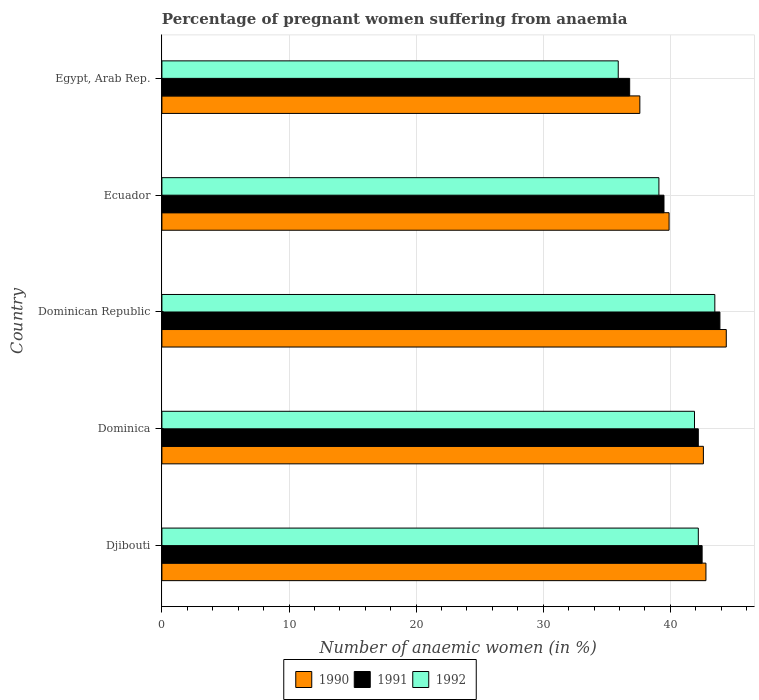How many groups of bars are there?
Offer a terse response. 5. How many bars are there on the 4th tick from the top?
Offer a very short reply. 3. How many bars are there on the 5th tick from the bottom?
Provide a succinct answer. 3. What is the label of the 2nd group of bars from the top?
Your answer should be compact. Ecuador. In how many cases, is the number of bars for a given country not equal to the number of legend labels?
Give a very brief answer. 0. What is the number of anaemic women in 1992 in Ecuador?
Offer a very short reply. 39.1. Across all countries, what is the maximum number of anaemic women in 1991?
Provide a succinct answer. 43.9. Across all countries, what is the minimum number of anaemic women in 1991?
Make the answer very short. 36.8. In which country was the number of anaemic women in 1990 maximum?
Provide a short and direct response. Dominican Republic. In which country was the number of anaemic women in 1992 minimum?
Your response must be concise. Egypt, Arab Rep. What is the total number of anaemic women in 1990 in the graph?
Ensure brevity in your answer.  207.3. What is the difference between the number of anaemic women in 1991 in Dominica and that in Dominican Republic?
Make the answer very short. -1.7. What is the difference between the number of anaemic women in 1992 in Djibouti and the number of anaemic women in 1991 in Ecuador?
Offer a very short reply. 2.7. What is the average number of anaemic women in 1992 per country?
Give a very brief answer. 40.52. What is the difference between the number of anaemic women in 1991 and number of anaemic women in 1992 in Ecuador?
Give a very brief answer. 0.4. In how many countries, is the number of anaemic women in 1991 greater than 8 %?
Your response must be concise. 5. What is the ratio of the number of anaemic women in 1991 in Dominican Republic to that in Ecuador?
Make the answer very short. 1.11. Is the number of anaemic women in 1990 in Dominica less than that in Ecuador?
Offer a very short reply. No. Is the difference between the number of anaemic women in 1991 in Dominica and Ecuador greater than the difference between the number of anaemic women in 1992 in Dominica and Ecuador?
Keep it short and to the point. No. What is the difference between the highest and the second highest number of anaemic women in 1990?
Offer a terse response. 1.6. What is the difference between the highest and the lowest number of anaemic women in 1992?
Your response must be concise. 7.6. In how many countries, is the number of anaemic women in 1990 greater than the average number of anaemic women in 1990 taken over all countries?
Provide a succinct answer. 3. What does the 1st bar from the top in Dominica represents?
Provide a short and direct response. 1992. What does the 1st bar from the bottom in Djibouti represents?
Provide a short and direct response. 1990. Is it the case that in every country, the sum of the number of anaemic women in 1990 and number of anaemic women in 1992 is greater than the number of anaemic women in 1991?
Provide a succinct answer. Yes. How many bars are there?
Offer a terse response. 15. Are all the bars in the graph horizontal?
Your answer should be compact. Yes. Does the graph contain any zero values?
Offer a very short reply. No. How many legend labels are there?
Keep it short and to the point. 3. What is the title of the graph?
Provide a short and direct response. Percentage of pregnant women suffering from anaemia. What is the label or title of the X-axis?
Offer a very short reply. Number of anaemic women (in %). What is the label or title of the Y-axis?
Make the answer very short. Country. What is the Number of anaemic women (in %) in 1990 in Djibouti?
Provide a succinct answer. 42.8. What is the Number of anaemic women (in %) in 1991 in Djibouti?
Keep it short and to the point. 42.5. What is the Number of anaemic women (in %) of 1992 in Djibouti?
Provide a short and direct response. 42.2. What is the Number of anaemic women (in %) in 1990 in Dominica?
Provide a succinct answer. 42.6. What is the Number of anaemic women (in %) in 1991 in Dominica?
Your answer should be very brief. 42.2. What is the Number of anaemic women (in %) in 1992 in Dominica?
Provide a short and direct response. 41.9. What is the Number of anaemic women (in %) of 1990 in Dominican Republic?
Offer a terse response. 44.4. What is the Number of anaemic women (in %) of 1991 in Dominican Republic?
Keep it short and to the point. 43.9. What is the Number of anaemic women (in %) of 1992 in Dominican Republic?
Provide a succinct answer. 43.5. What is the Number of anaemic women (in %) in 1990 in Ecuador?
Offer a terse response. 39.9. What is the Number of anaemic women (in %) of 1991 in Ecuador?
Ensure brevity in your answer.  39.5. What is the Number of anaemic women (in %) in 1992 in Ecuador?
Give a very brief answer. 39.1. What is the Number of anaemic women (in %) of 1990 in Egypt, Arab Rep.?
Keep it short and to the point. 37.6. What is the Number of anaemic women (in %) of 1991 in Egypt, Arab Rep.?
Your response must be concise. 36.8. What is the Number of anaemic women (in %) in 1992 in Egypt, Arab Rep.?
Your response must be concise. 35.9. Across all countries, what is the maximum Number of anaemic women (in %) in 1990?
Your answer should be compact. 44.4. Across all countries, what is the maximum Number of anaemic women (in %) of 1991?
Offer a terse response. 43.9. Across all countries, what is the maximum Number of anaemic women (in %) in 1992?
Provide a short and direct response. 43.5. Across all countries, what is the minimum Number of anaemic women (in %) in 1990?
Provide a succinct answer. 37.6. Across all countries, what is the minimum Number of anaemic women (in %) of 1991?
Offer a terse response. 36.8. Across all countries, what is the minimum Number of anaemic women (in %) of 1992?
Keep it short and to the point. 35.9. What is the total Number of anaemic women (in %) of 1990 in the graph?
Offer a terse response. 207.3. What is the total Number of anaemic women (in %) in 1991 in the graph?
Give a very brief answer. 204.9. What is the total Number of anaemic women (in %) in 1992 in the graph?
Provide a short and direct response. 202.6. What is the difference between the Number of anaemic women (in %) of 1990 in Djibouti and that in Dominica?
Provide a succinct answer. 0.2. What is the difference between the Number of anaemic women (in %) of 1991 in Djibouti and that in Dominica?
Keep it short and to the point. 0.3. What is the difference between the Number of anaemic women (in %) of 1992 in Djibouti and that in Dominica?
Provide a short and direct response. 0.3. What is the difference between the Number of anaemic women (in %) of 1990 in Djibouti and that in Dominican Republic?
Make the answer very short. -1.6. What is the difference between the Number of anaemic women (in %) of 1992 in Djibouti and that in Dominican Republic?
Provide a short and direct response. -1.3. What is the difference between the Number of anaemic women (in %) in 1990 in Djibouti and that in Ecuador?
Offer a very short reply. 2.9. What is the difference between the Number of anaemic women (in %) of 1991 in Djibouti and that in Ecuador?
Provide a succinct answer. 3. What is the difference between the Number of anaemic women (in %) of 1992 in Djibouti and that in Ecuador?
Give a very brief answer. 3.1. What is the difference between the Number of anaemic women (in %) in 1990 in Djibouti and that in Egypt, Arab Rep.?
Offer a very short reply. 5.2. What is the difference between the Number of anaemic women (in %) of 1991 in Djibouti and that in Egypt, Arab Rep.?
Make the answer very short. 5.7. What is the difference between the Number of anaemic women (in %) in 1990 in Dominica and that in Dominican Republic?
Offer a very short reply. -1.8. What is the difference between the Number of anaemic women (in %) in 1991 in Dominica and that in Dominican Republic?
Offer a very short reply. -1.7. What is the difference between the Number of anaemic women (in %) of 1990 in Dominica and that in Ecuador?
Provide a short and direct response. 2.7. What is the difference between the Number of anaemic women (in %) in 1990 in Dominica and that in Egypt, Arab Rep.?
Your answer should be compact. 5. What is the difference between the Number of anaemic women (in %) in 1991 in Dominica and that in Egypt, Arab Rep.?
Keep it short and to the point. 5.4. What is the difference between the Number of anaemic women (in %) in 1992 in Dominica and that in Egypt, Arab Rep.?
Make the answer very short. 6. What is the difference between the Number of anaemic women (in %) in 1991 in Dominican Republic and that in Ecuador?
Your answer should be compact. 4.4. What is the difference between the Number of anaemic women (in %) in 1990 in Djibouti and the Number of anaemic women (in %) in 1991 in Dominica?
Give a very brief answer. 0.6. What is the difference between the Number of anaemic women (in %) of 1990 in Djibouti and the Number of anaemic women (in %) of 1991 in Dominican Republic?
Your response must be concise. -1.1. What is the difference between the Number of anaemic women (in %) of 1990 in Djibouti and the Number of anaemic women (in %) of 1992 in Dominican Republic?
Your answer should be very brief. -0.7. What is the difference between the Number of anaemic women (in %) in 1991 in Djibouti and the Number of anaemic women (in %) in 1992 in Dominican Republic?
Your answer should be compact. -1. What is the difference between the Number of anaemic women (in %) in 1990 in Djibouti and the Number of anaemic women (in %) in 1991 in Ecuador?
Ensure brevity in your answer.  3.3. What is the difference between the Number of anaemic women (in %) of 1990 in Djibouti and the Number of anaemic women (in %) of 1991 in Egypt, Arab Rep.?
Your response must be concise. 6. What is the difference between the Number of anaemic women (in %) of 1990 in Djibouti and the Number of anaemic women (in %) of 1992 in Egypt, Arab Rep.?
Provide a short and direct response. 6.9. What is the difference between the Number of anaemic women (in %) in 1990 in Dominica and the Number of anaemic women (in %) in 1991 in Dominican Republic?
Offer a terse response. -1.3. What is the difference between the Number of anaemic women (in %) of 1990 in Dominica and the Number of anaemic women (in %) of 1992 in Dominican Republic?
Keep it short and to the point. -0.9. What is the difference between the Number of anaemic women (in %) in 1991 in Dominica and the Number of anaemic women (in %) in 1992 in Dominican Republic?
Ensure brevity in your answer.  -1.3. What is the difference between the Number of anaemic women (in %) of 1990 in Dominica and the Number of anaemic women (in %) of 1991 in Egypt, Arab Rep.?
Your answer should be compact. 5.8. What is the difference between the Number of anaemic women (in %) in 1990 in Dominica and the Number of anaemic women (in %) in 1992 in Egypt, Arab Rep.?
Your answer should be compact. 6.7. What is the difference between the Number of anaemic women (in %) of 1991 in Dominica and the Number of anaemic women (in %) of 1992 in Egypt, Arab Rep.?
Your answer should be very brief. 6.3. What is the difference between the Number of anaemic women (in %) in 1990 in Dominican Republic and the Number of anaemic women (in %) in 1991 in Egypt, Arab Rep.?
Offer a very short reply. 7.6. What is the average Number of anaemic women (in %) in 1990 per country?
Provide a short and direct response. 41.46. What is the average Number of anaemic women (in %) of 1991 per country?
Offer a terse response. 40.98. What is the average Number of anaemic women (in %) in 1992 per country?
Ensure brevity in your answer.  40.52. What is the difference between the Number of anaemic women (in %) of 1990 and Number of anaemic women (in %) of 1992 in Djibouti?
Offer a very short reply. 0.6. What is the difference between the Number of anaemic women (in %) of 1991 and Number of anaemic women (in %) of 1992 in Dominican Republic?
Give a very brief answer. 0.4. What is the difference between the Number of anaemic women (in %) of 1990 and Number of anaemic women (in %) of 1991 in Ecuador?
Your answer should be compact. 0.4. What is the difference between the Number of anaemic women (in %) of 1990 and Number of anaemic women (in %) of 1991 in Egypt, Arab Rep.?
Offer a very short reply. 0.8. What is the difference between the Number of anaemic women (in %) in 1990 and Number of anaemic women (in %) in 1992 in Egypt, Arab Rep.?
Give a very brief answer. 1.7. What is the difference between the Number of anaemic women (in %) of 1991 and Number of anaemic women (in %) of 1992 in Egypt, Arab Rep.?
Ensure brevity in your answer.  0.9. What is the ratio of the Number of anaemic women (in %) of 1990 in Djibouti to that in Dominica?
Keep it short and to the point. 1. What is the ratio of the Number of anaemic women (in %) of 1991 in Djibouti to that in Dominica?
Your answer should be very brief. 1.01. What is the ratio of the Number of anaemic women (in %) of 1992 in Djibouti to that in Dominica?
Offer a terse response. 1.01. What is the ratio of the Number of anaemic women (in %) of 1991 in Djibouti to that in Dominican Republic?
Offer a very short reply. 0.97. What is the ratio of the Number of anaemic women (in %) in 1992 in Djibouti to that in Dominican Republic?
Ensure brevity in your answer.  0.97. What is the ratio of the Number of anaemic women (in %) of 1990 in Djibouti to that in Ecuador?
Provide a succinct answer. 1.07. What is the ratio of the Number of anaemic women (in %) of 1991 in Djibouti to that in Ecuador?
Provide a short and direct response. 1.08. What is the ratio of the Number of anaemic women (in %) of 1992 in Djibouti to that in Ecuador?
Give a very brief answer. 1.08. What is the ratio of the Number of anaemic women (in %) in 1990 in Djibouti to that in Egypt, Arab Rep.?
Keep it short and to the point. 1.14. What is the ratio of the Number of anaemic women (in %) of 1991 in Djibouti to that in Egypt, Arab Rep.?
Provide a short and direct response. 1.15. What is the ratio of the Number of anaemic women (in %) in 1992 in Djibouti to that in Egypt, Arab Rep.?
Keep it short and to the point. 1.18. What is the ratio of the Number of anaemic women (in %) in 1990 in Dominica to that in Dominican Republic?
Give a very brief answer. 0.96. What is the ratio of the Number of anaemic women (in %) of 1991 in Dominica to that in Dominican Republic?
Offer a very short reply. 0.96. What is the ratio of the Number of anaemic women (in %) of 1992 in Dominica to that in Dominican Republic?
Keep it short and to the point. 0.96. What is the ratio of the Number of anaemic women (in %) in 1990 in Dominica to that in Ecuador?
Offer a terse response. 1.07. What is the ratio of the Number of anaemic women (in %) in 1991 in Dominica to that in Ecuador?
Your response must be concise. 1.07. What is the ratio of the Number of anaemic women (in %) of 1992 in Dominica to that in Ecuador?
Provide a short and direct response. 1.07. What is the ratio of the Number of anaemic women (in %) in 1990 in Dominica to that in Egypt, Arab Rep.?
Give a very brief answer. 1.13. What is the ratio of the Number of anaemic women (in %) in 1991 in Dominica to that in Egypt, Arab Rep.?
Ensure brevity in your answer.  1.15. What is the ratio of the Number of anaemic women (in %) of 1992 in Dominica to that in Egypt, Arab Rep.?
Give a very brief answer. 1.17. What is the ratio of the Number of anaemic women (in %) in 1990 in Dominican Republic to that in Ecuador?
Give a very brief answer. 1.11. What is the ratio of the Number of anaemic women (in %) of 1991 in Dominican Republic to that in Ecuador?
Your answer should be very brief. 1.11. What is the ratio of the Number of anaemic women (in %) in 1992 in Dominican Republic to that in Ecuador?
Your response must be concise. 1.11. What is the ratio of the Number of anaemic women (in %) of 1990 in Dominican Republic to that in Egypt, Arab Rep.?
Ensure brevity in your answer.  1.18. What is the ratio of the Number of anaemic women (in %) in 1991 in Dominican Republic to that in Egypt, Arab Rep.?
Your answer should be compact. 1.19. What is the ratio of the Number of anaemic women (in %) in 1992 in Dominican Republic to that in Egypt, Arab Rep.?
Ensure brevity in your answer.  1.21. What is the ratio of the Number of anaemic women (in %) of 1990 in Ecuador to that in Egypt, Arab Rep.?
Offer a terse response. 1.06. What is the ratio of the Number of anaemic women (in %) in 1991 in Ecuador to that in Egypt, Arab Rep.?
Keep it short and to the point. 1.07. What is the ratio of the Number of anaemic women (in %) of 1992 in Ecuador to that in Egypt, Arab Rep.?
Make the answer very short. 1.09. What is the difference between the highest and the second highest Number of anaemic women (in %) of 1991?
Offer a terse response. 1.4. What is the difference between the highest and the lowest Number of anaemic women (in %) in 1991?
Your answer should be very brief. 7.1. What is the difference between the highest and the lowest Number of anaemic women (in %) of 1992?
Offer a terse response. 7.6. 